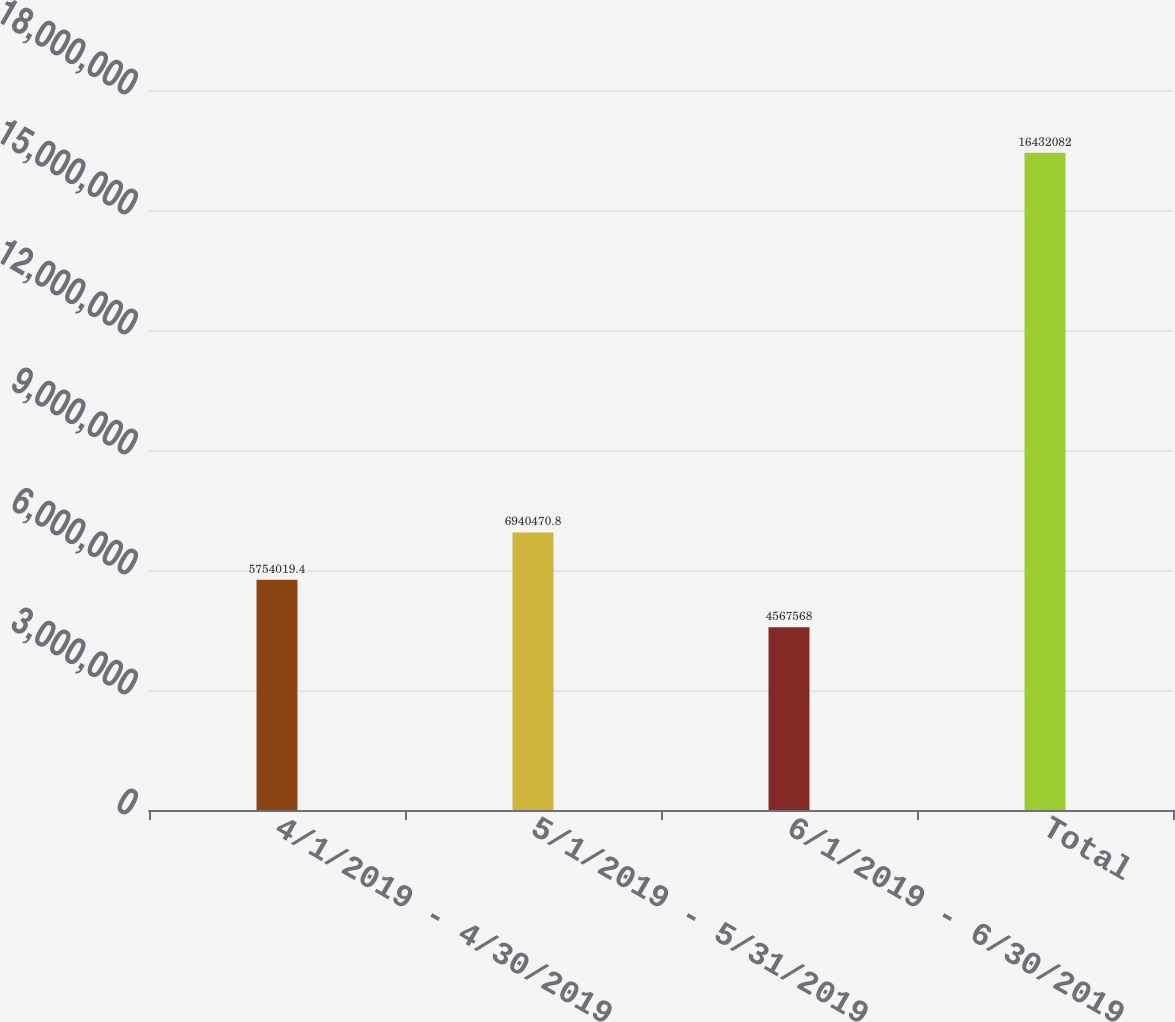Convert chart to OTSL. <chart><loc_0><loc_0><loc_500><loc_500><bar_chart><fcel>4/1/2019 - 4/30/2019<fcel>5/1/2019 - 5/31/2019<fcel>6/1/2019 - 6/30/2019<fcel>Total<nl><fcel>5.75402e+06<fcel>6.94047e+06<fcel>4.56757e+06<fcel>1.64321e+07<nl></chart> 